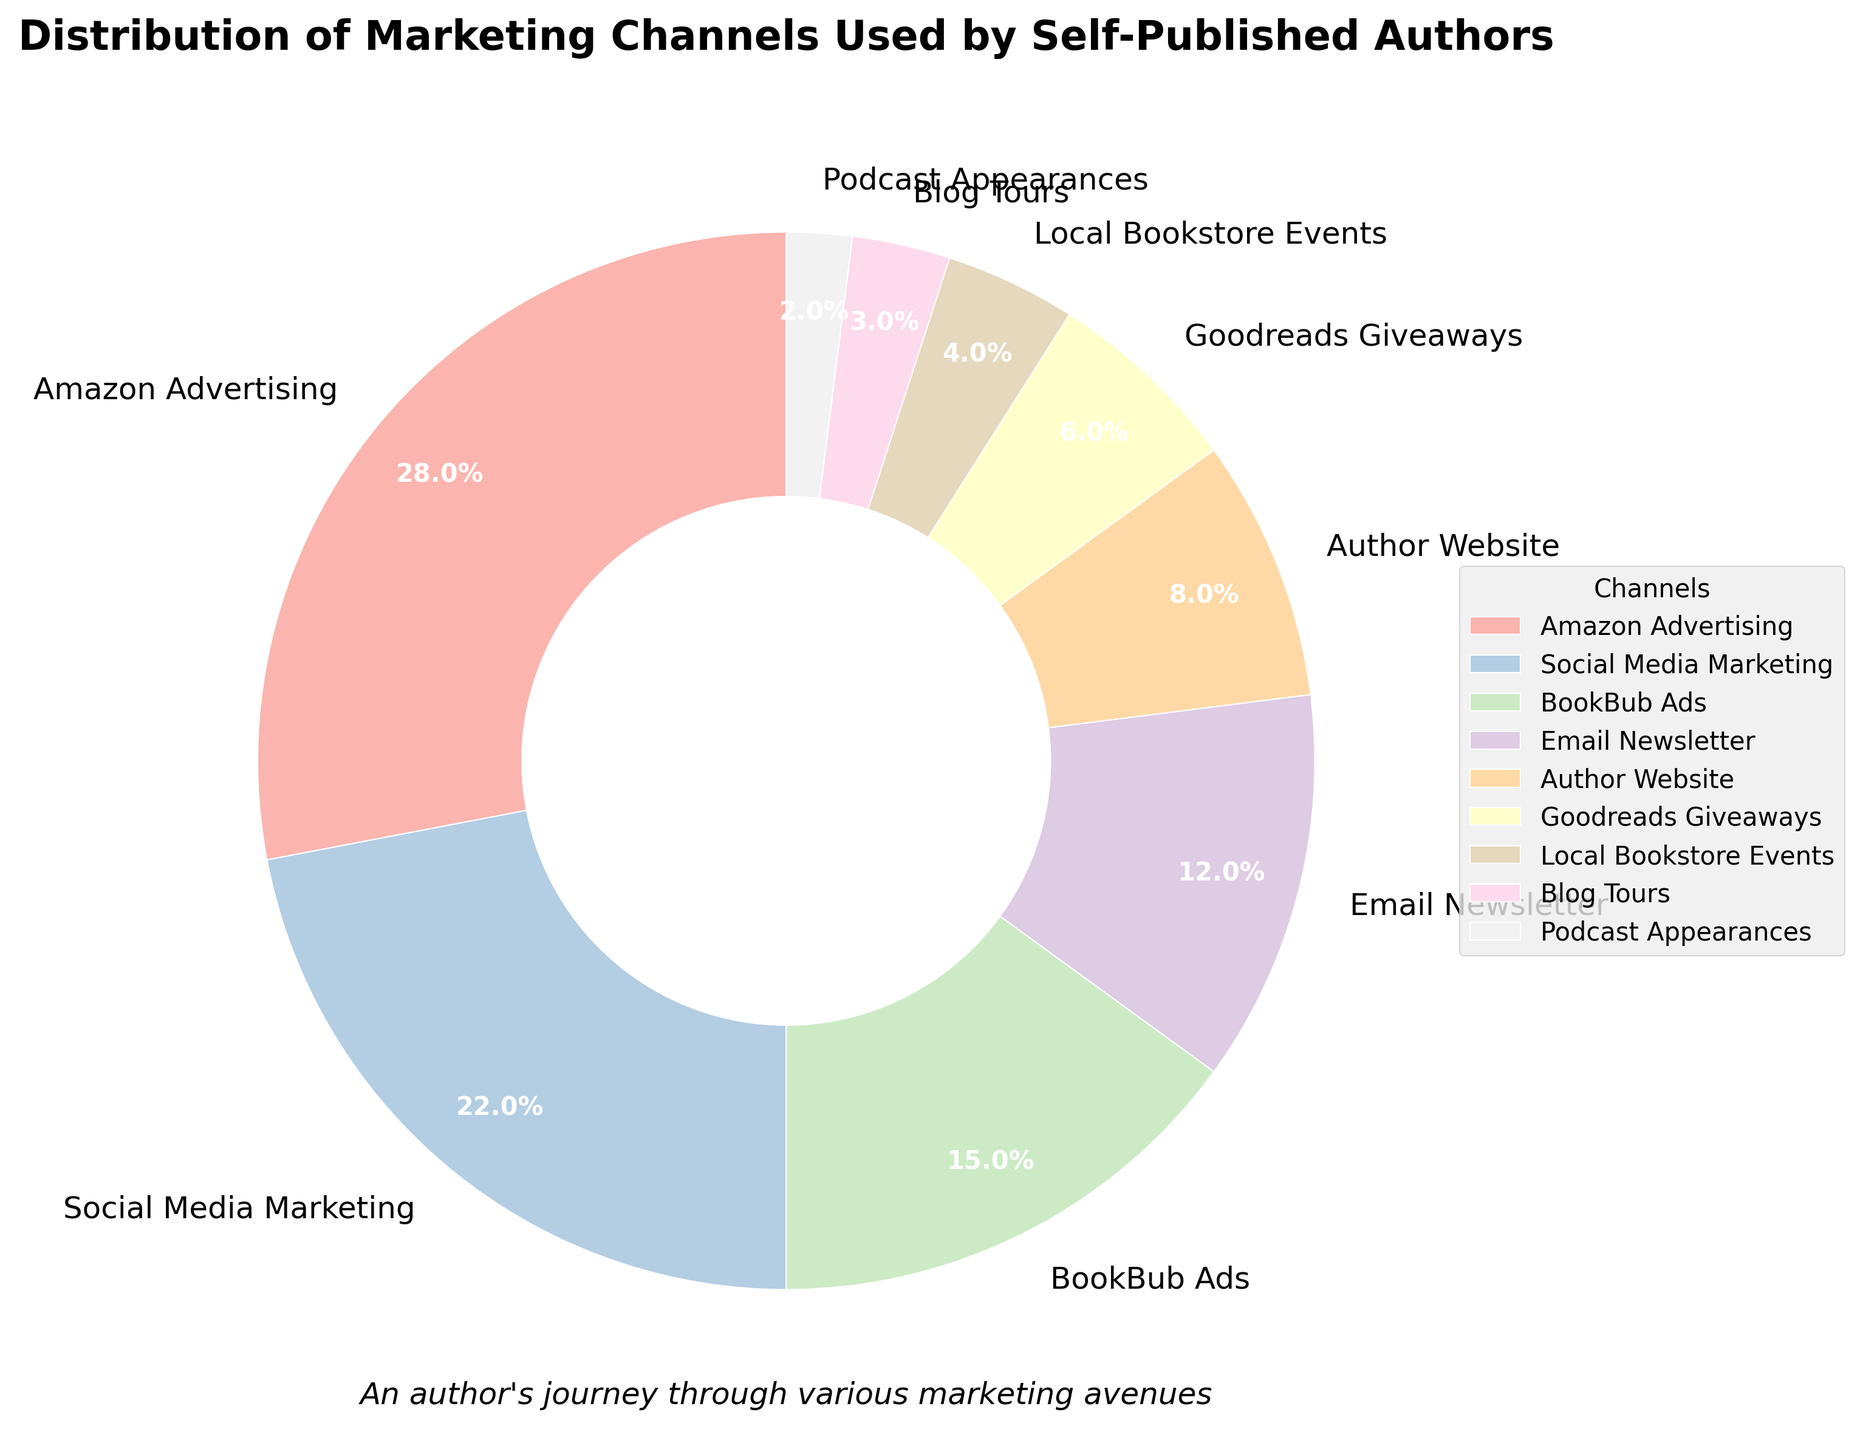What is the percentage of authors using Amazon Advertising? The slice labeled "Amazon Advertising" on the pie chart indicates 28%, representing the percentage of self-published authors using this channel.
Answer: 28% Which marketing channel has the smallest percentage of use? The smallest slice on the pie chart, labeled "Podcast Appearances," shows 2%, indicating the least used marketing channel among self-published authors.
Answer: Podcast Appearances What two categories together make up 30% of the total? Adding together the percentages for Author Website (8%) and Email Newsletter (12%) results in 20%. Therefore, they don't sum up to 30%. However, "Local Bookstore Events" (4%) and "Goodreads Giveaways" (6%) sum up to 10%. "Social Media Marketing" (22%) alone could combine with many others to total 30%, like combining with "Email Newsletter" (12%) sums up to 34%, slightly higher. "BookBub Ads" (15%) and "Email Newsletter" (12%) together make 27%, not 30%. Thus, the best answer is Social Media Marketing and any smaller value like "Local Bookstore Events" (4%) to surpass the 30%.
Answer: None exactly 30%, closest is various sums like "Social Media Marketing" (22%) + "Local Bookstore Events" (4%) = 26% How much more popular is Amazon Advertising compared to Goodreads Giveaways? The percentage for Amazon Advertising is 28%, and for "Goodreads Giveaways" it is 6%. The difference between them is 28% - 6% = 22%.
Answer: 22% Which two channels have a combined total just over a quarter (around 25%)? Adding up the percentages for Author Website (8%) and Email Newsletter (12%) gives 20%, which is less. If combined with "Goodreads Giveaways" (6%) the total is 26%, just over a quarter.
Answer: Author Website and Email Newsletter (combined with Goodreads Giveaways if more precision) What percentage of channels are used less than 10%? Identify channels with percentages less than 10%: Author Website (8%), Goodreads Giveaways (6%), Local Bookstore Events (4%), Blog Tours (3%), and Podcast Appearances (2%). There are 5 such channels.
Answer: Five channels Is Social Media Marketing or BookBub Ads used more frequently? By looking at the slices, Social Media Marketing is labeled 22% and BookBub Ads 15%. Social Media Marketing has a bigger percentage.
Answer: Social Media Marketing What is the combined percentage of Blog Tours, Podcast Appearances, and Local Bookstore Events? Adding the percentages for Blog Tours (3%), Podcast Appearances (2%), and Local Bookstore Events (4%) results in 3% + 2% + 4% = 9%.
Answer: 9% Which channel has a larger share: Email Newsletter or Author Website? Based on the slices on the pie chart, "Email Newsletter" with 12% is larger than "Author Website" with 8%.
Answer: Email Newsletter 